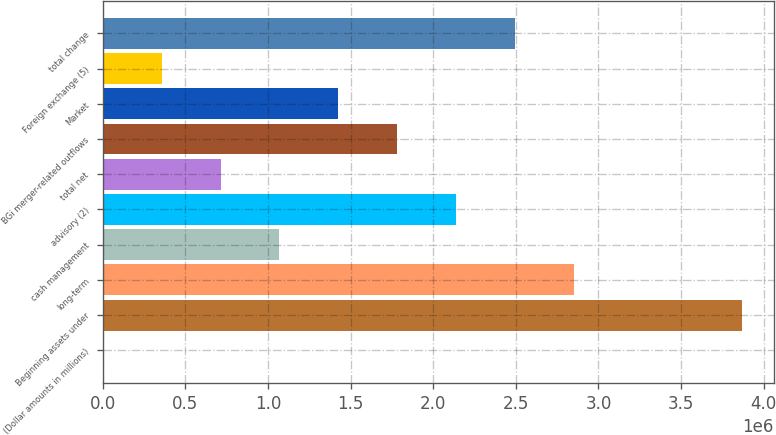Convert chart. <chart><loc_0><loc_0><loc_500><loc_500><bar_chart><fcel>(Dollar amounts in millions)<fcel>Beginning assets under<fcel>long-term<fcel>cash management<fcel>advisory (2)<fcel>total net<fcel>BGi merger-related outflows<fcel>Market<fcel>Foreign exchange (5)<fcel>total change<nl><fcel>2011<fcel>3.86858e+06<fcel>2.84918e+06<fcel>1.0697e+06<fcel>2.13739e+06<fcel>713802<fcel>1.78149e+06<fcel>1.42559e+06<fcel>357907<fcel>2.49328e+06<nl></chart> 